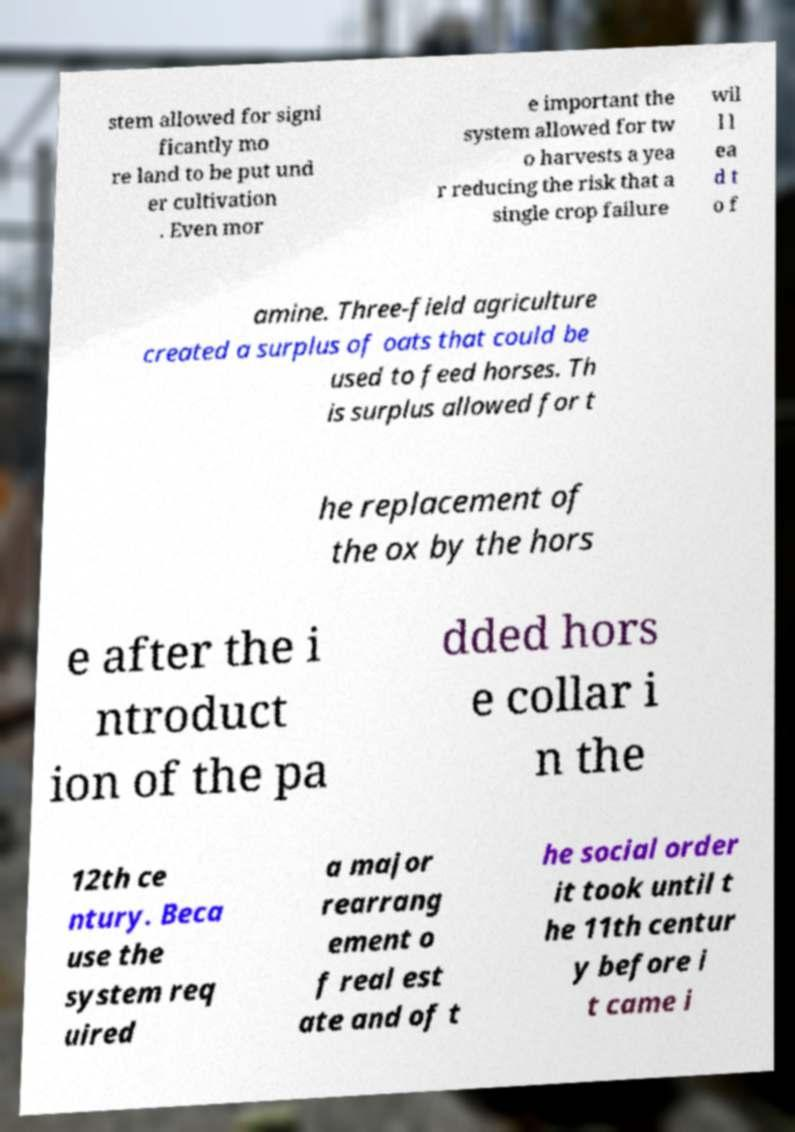Please identify and transcribe the text found in this image. stem allowed for signi ficantly mo re land to be put und er cultivation . Even mor e important the system allowed for tw o harvests a yea r reducing the risk that a single crop failure wil l l ea d t o f amine. Three-field agriculture created a surplus of oats that could be used to feed horses. Th is surplus allowed for t he replacement of the ox by the hors e after the i ntroduct ion of the pa dded hors e collar i n the 12th ce ntury. Beca use the system req uired a major rearrang ement o f real est ate and of t he social order it took until t he 11th centur y before i t came i 